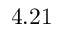Convert formula to latex. <formula><loc_0><loc_0><loc_500><loc_500>4 . 2 1</formula> 